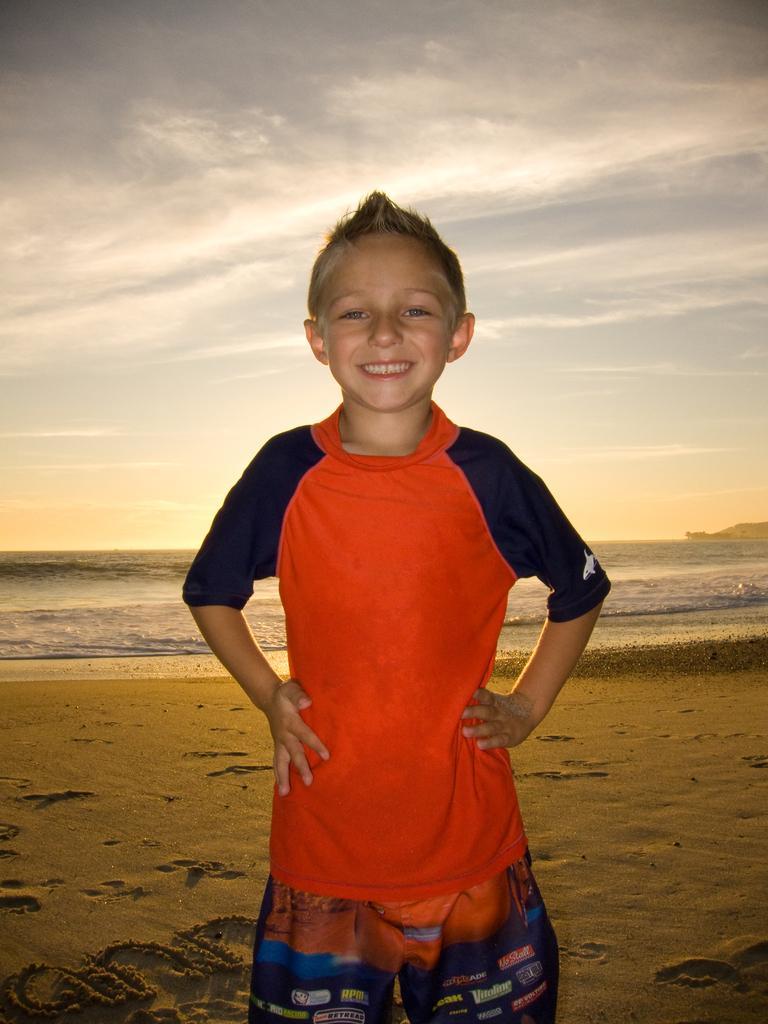Please provide a concise description of this image. In this image we can see a boy wearing dress is standing on the shore. In the background, we can see the water and the cloudy sky. 